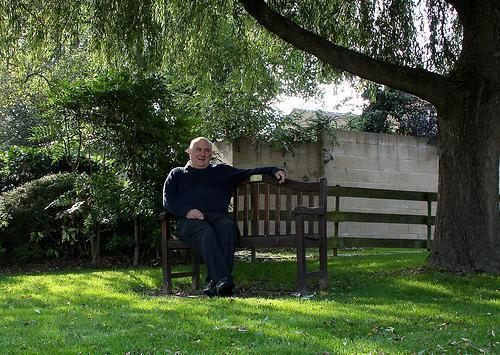How many people are in the picture?
Give a very brief answer. 1. 